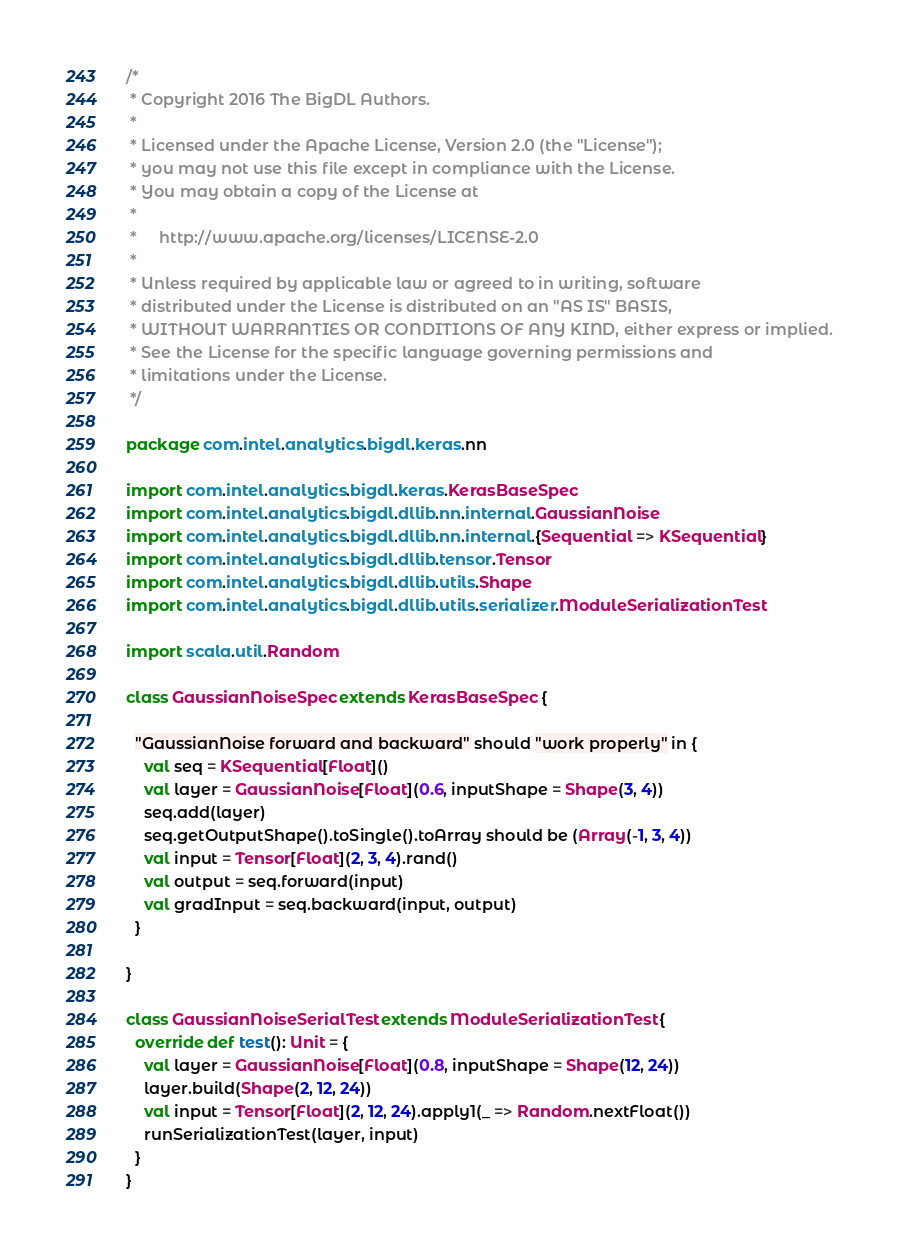Convert code to text. <code><loc_0><loc_0><loc_500><loc_500><_Scala_>/*
 * Copyright 2016 The BigDL Authors.
 *
 * Licensed under the Apache License, Version 2.0 (the "License");
 * you may not use this file except in compliance with the License.
 * You may obtain a copy of the License at
 *
 *     http://www.apache.org/licenses/LICENSE-2.0
 *
 * Unless required by applicable law or agreed to in writing, software
 * distributed under the License is distributed on an "AS IS" BASIS,
 * WITHOUT WARRANTIES OR CONDITIONS OF ANY KIND, either express or implied.
 * See the License for the specific language governing permissions and
 * limitations under the License.
 */

package com.intel.analytics.bigdl.keras.nn

import com.intel.analytics.bigdl.keras.KerasBaseSpec
import com.intel.analytics.bigdl.dllib.nn.internal.GaussianNoise
import com.intel.analytics.bigdl.dllib.nn.internal.{Sequential => KSequential}
import com.intel.analytics.bigdl.dllib.tensor.Tensor
import com.intel.analytics.bigdl.dllib.utils.Shape
import com.intel.analytics.bigdl.dllib.utils.serializer.ModuleSerializationTest

import scala.util.Random

class GaussianNoiseSpec extends KerasBaseSpec {

  "GaussianNoise forward and backward" should "work properly" in {
    val seq = KSequential[Float]()
    val layer = GaussianNoise[Float](0.6, inputShape = Shape(3, 4))
    seq.add(layer)
    seq.getOutputShape().toSingle().toArray should be (Array(-1, 3, 4))
    val input = Tensor[Float](2, 3, 4).rand()
    val output = seq.forward(input)
    val gradInput = seq.backward(input, output)
  }

}

class GaussianNoiseSerialTest extends ModuleSerializationTest {
  override def test(): Unit = {
    val layer = GaussianNoise[Float](0.8, inputShape = Shape(12, 24))
    layer.build(Shape(2, 12, 24))
    val input = Tensor[Float](2, 12, 24).apply1(_ => Random.nextFloat())
    runSerializationTest(layer, input)
  }
}
</code> 